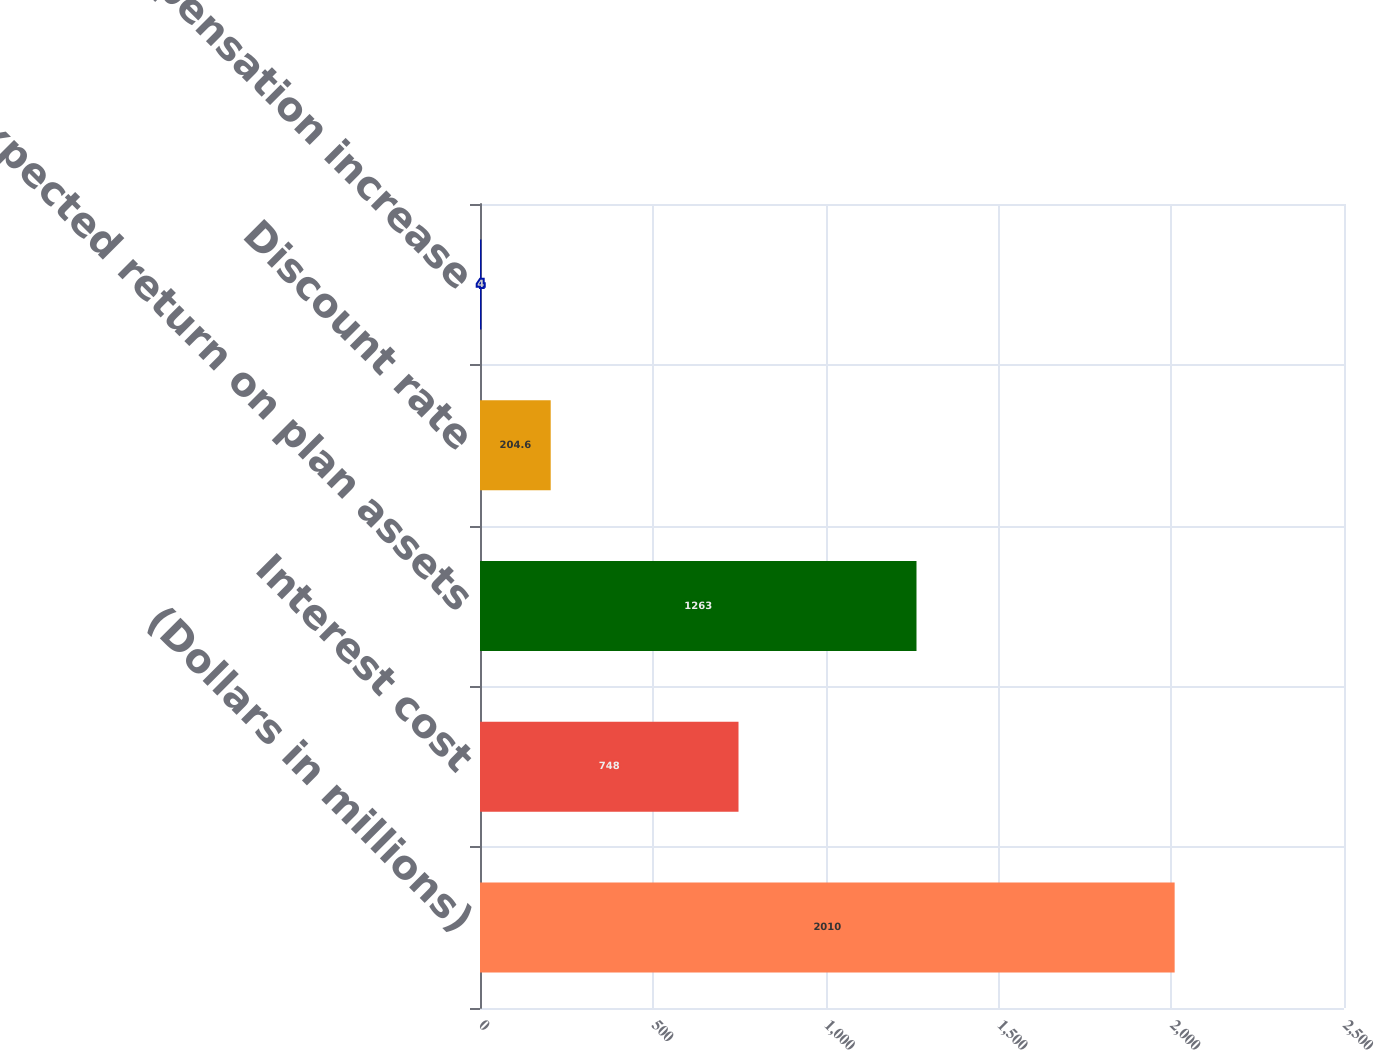Convert chart. <chart><loc_0><loc_0><loc_500><loc_500><bar_chart><fcel>(Dollars in millions)<fcel>Interest cost<fcel>Expected return on plan assets<fcel>Discount rate<fcel>Rate of compensation increase<nl><fcel>2010<fcel>748<fcel>1263<fcel>204.6<fcel>4<nl></chart> 